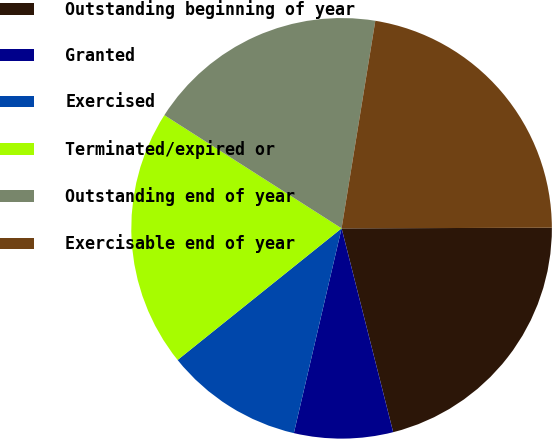<chart> <loc_0><loc_0><loc_500><loc_500><pie_chart><fcel>Outstanding beginning of year<fcel>Granted<fcel>Exercised<fcel>Terminated/expired or<fcel>Outstanding end of year<fcel>Exercisable end of year<nl><fcel>21.1%<fcel>7.59%<fcel>10.59%<fcel>19.81%<fcel>18.52%<fcel>22.39%<nl></chart> 